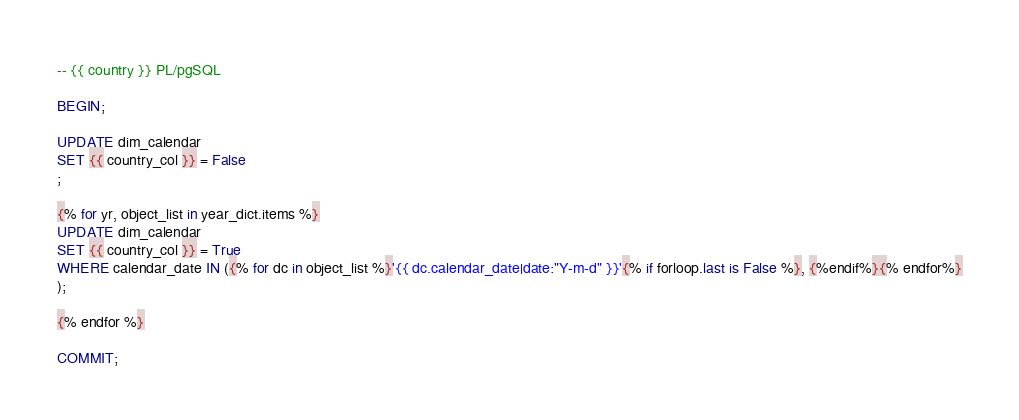<code> <loc_0><loc_0><loc_500><loc_500><_SQL_>-- {{ country }} PL/pgSQL

BEGIN;

UPDATE dim_calendar
SET {{ country_col }} = False
;

{% for yr, object_list in year_dict.items %}
UPDATE dim_calendar
SET {{ country_col }} = True
WHERE calendar_date IN ({% for dc in object_list %}'{{ dc.calendar_date|date:"Y-m-d" }}'{% if forloop.last is False %}, {%endif%}{% endfor%}
);

{% endfor %}

COMMIT;</code> 